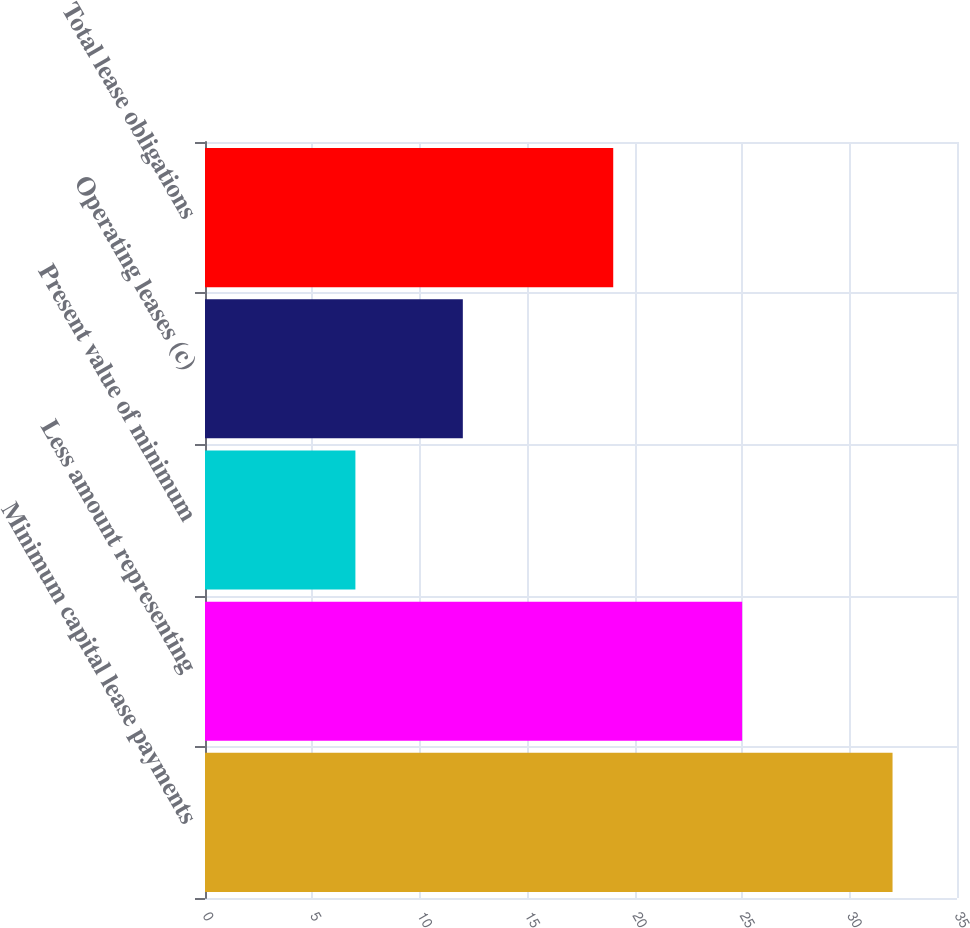<chart> <loc_0><loc_0><loc_500><loc_500><bar_chart><fcel>Minimum capital lease payments<fcel>Less amount representing<fcel>Present value of minimum<fcel>Operating leases (c)<fcel>Total lease obligations<nl><fcel>32<fcel>25<fcel>7<fcel>12<fcel>19<nl></chart> 